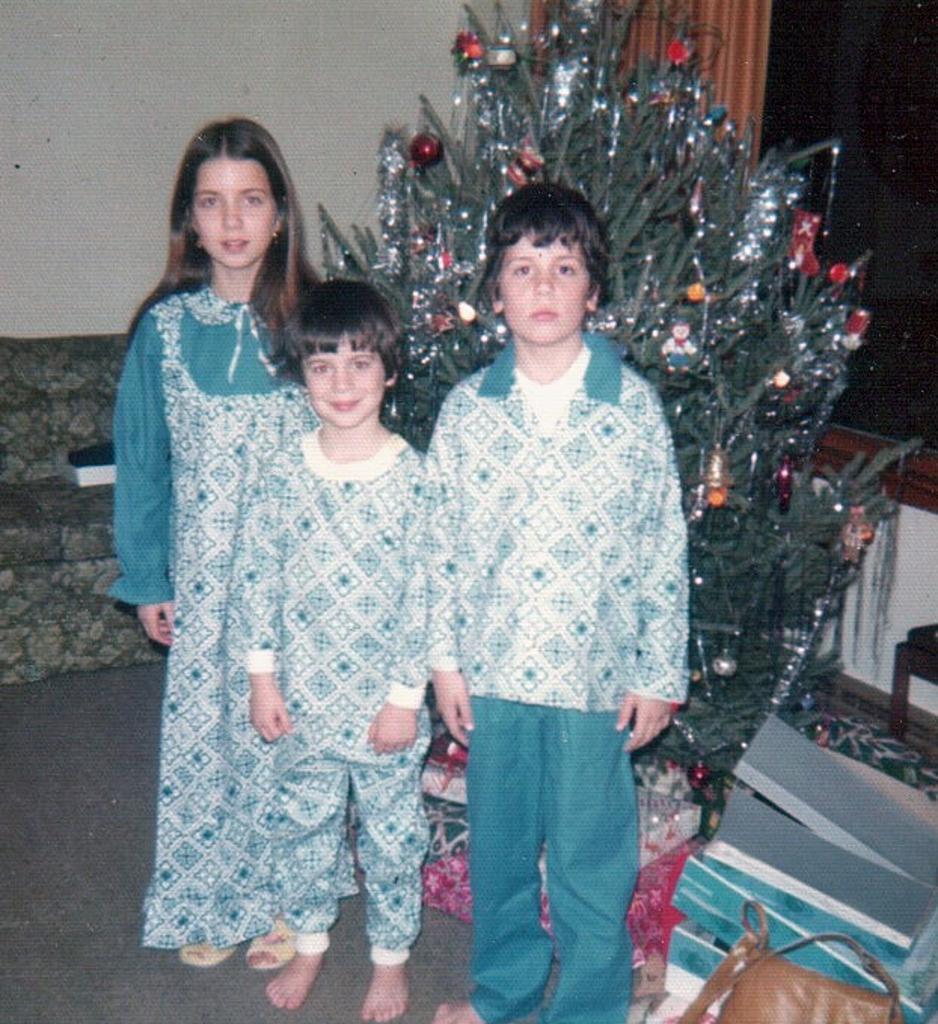In one or two sentences, can you explain what this image depicts? In this image we can see group of children are standing, there is a tree, there is a sofa on the carpet, there is a wall. 